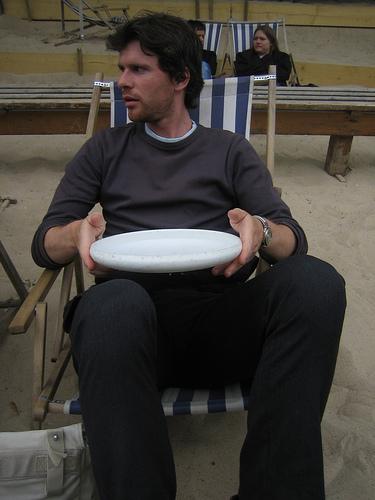Did he eat all of it?
Write a very short answer. Yes. What is the man holding in his hands?
Quick response, please. Frisbee. Is there sand on the ground?
Concise answer only. Yes. Is the white object a frisbee?
Concise answer only. Yes. 